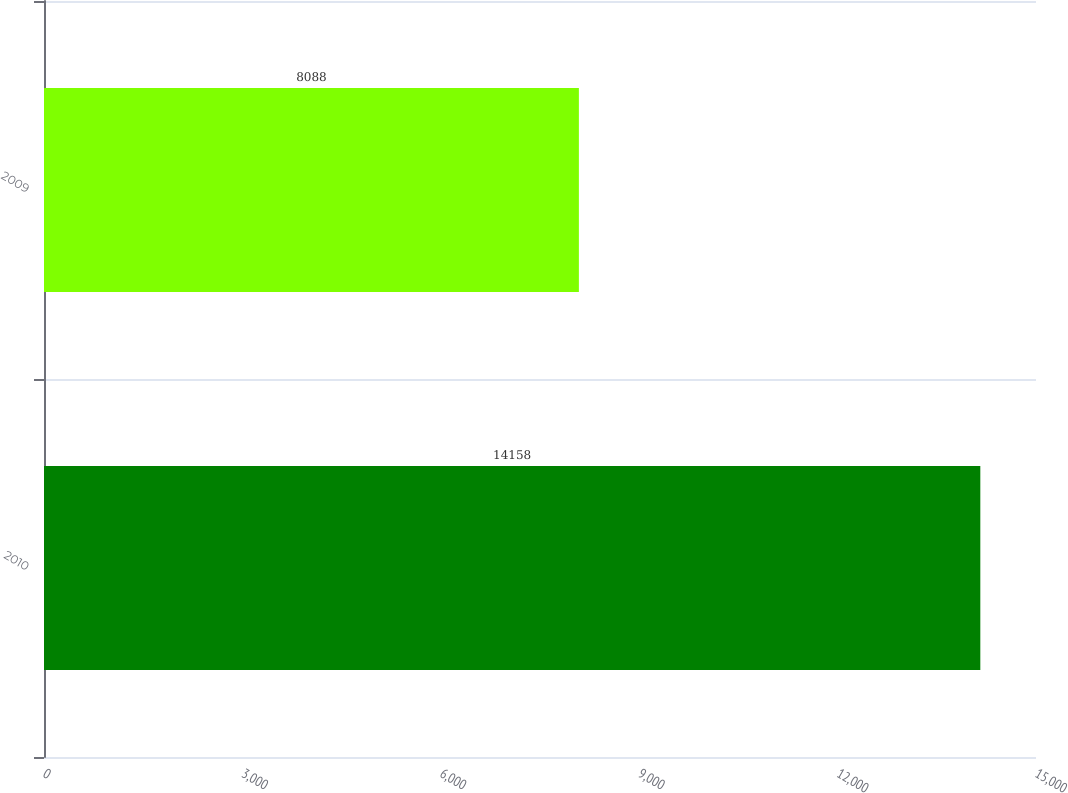Convert chart to OTSL. <chart><loc_0><loc_0><loc_500><loc_500><bar_chart><fcel>2010<fcel>2009<nl><fcel>14158<fcel>8088<nl></chart> 